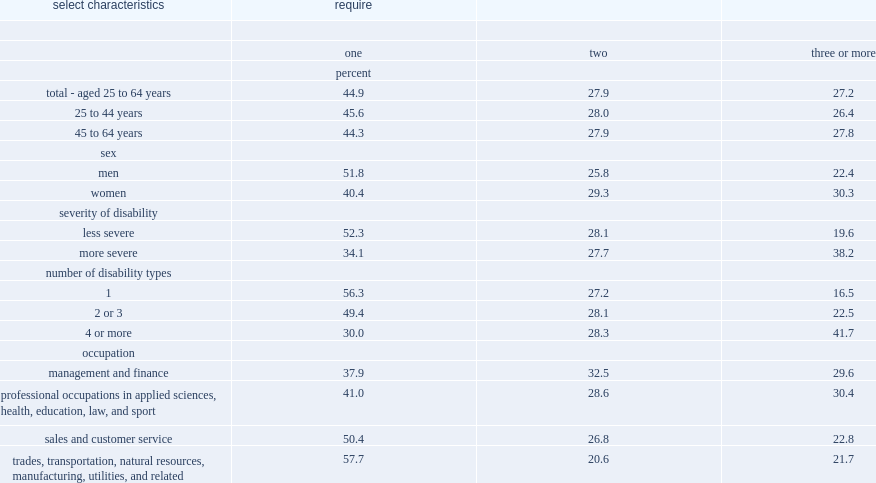Which sex were more likely to require only one wpa, male or female? 51.8. Employees with which kind of severity of disability were more likely to require only one wpa? 52.3. Employees with how many disability types were more likely to require only one wpa? 56.3. What were the occupations of employees who were more likely to require only one wpa? 57.7 50.4. Which sex were more likely to require three or more wpa? Women. Employees with which kind of severity of disability were more likely to require three or more wpa? More severe. Employees with how many disability types were more likely to require three or more wpa ? 41.7. 